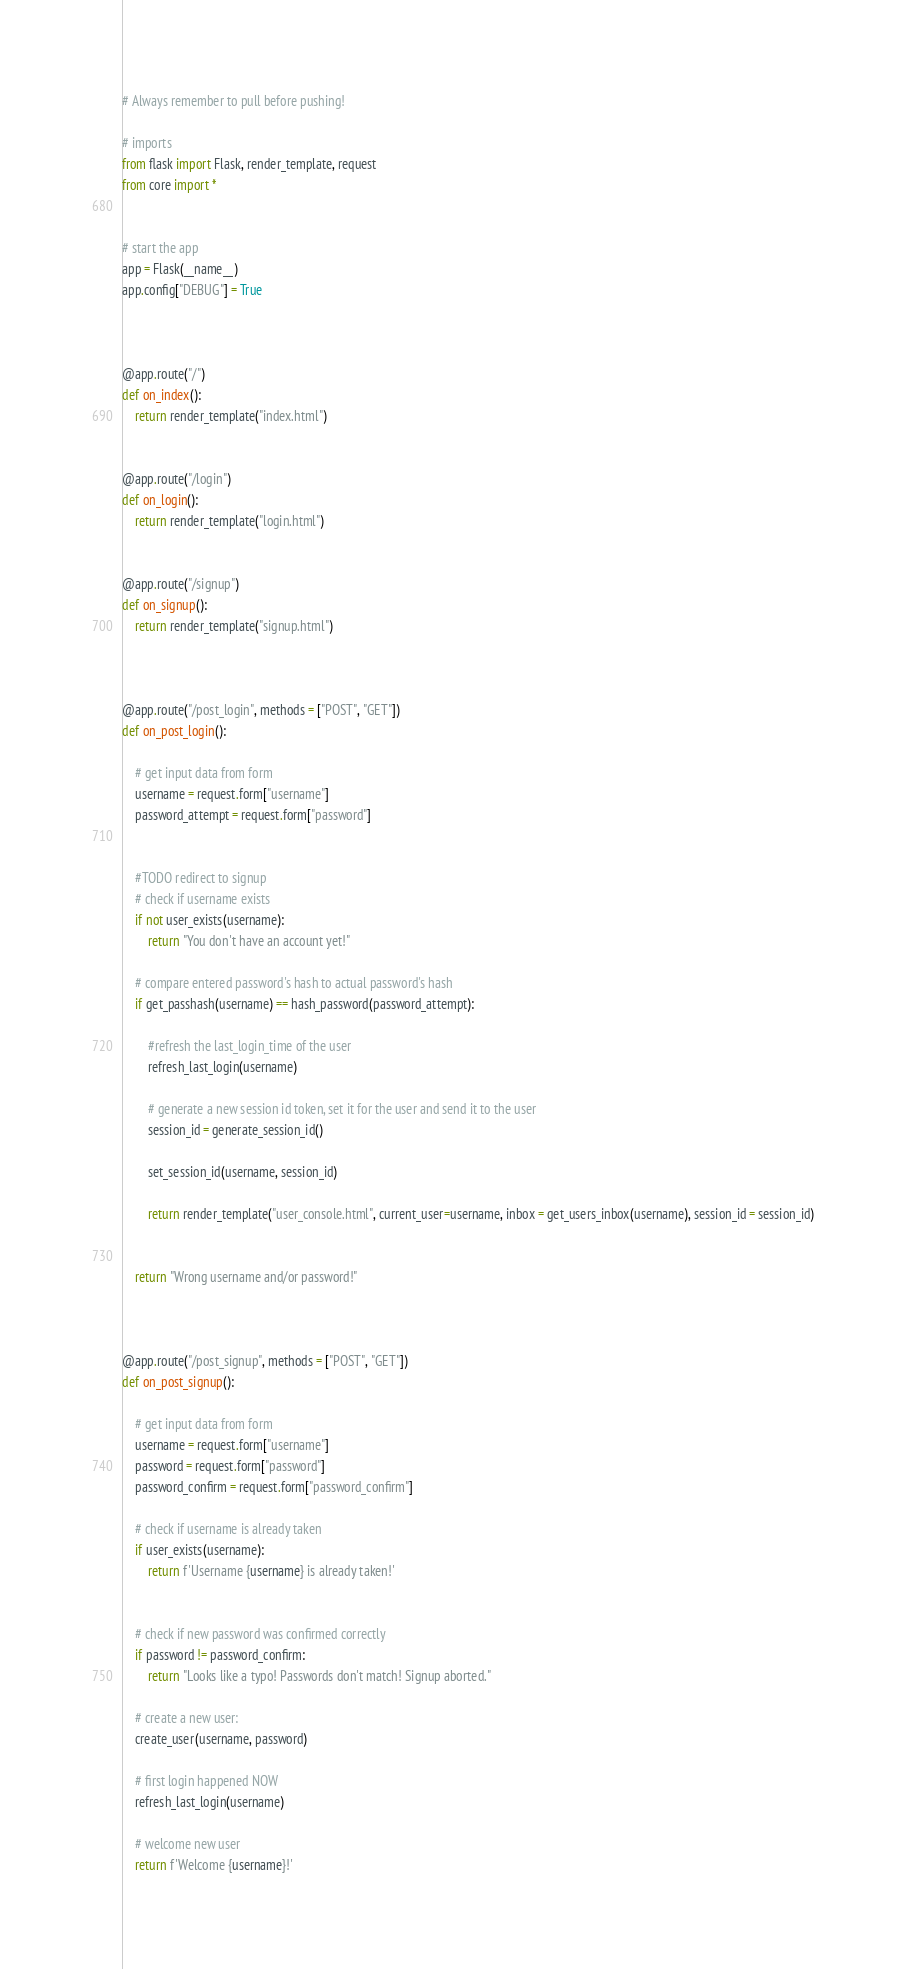<code> <loc_0><loc_0><loc_500><loc_500><_Python_># Always remember to pull before pushing!

# imports
from flask import Flask, render_template, request
from core import *


# start the app
app = Flask(__name__)
app.config["DEBUG"] = True



@app.route("/")
def on_index():
    return render_template("index.html")


@app.route("/login")
def on_login():
    return render_template("login.html")


@app.route("/signup")
def on_signup():
    return render_template("signup.html")



@app.route("/post_login", methods = ["POST", "GET"])
def on_post_login():

    # get input data from form
    username = request.form["username"]
    password_attempt = request.form["password"]


    #TODO redirect to signup
    # check if username exists
    if not user_exists(username):
        return "You don't have an account yet!"

    # compare entered password's hash to actual password's hash
    if get_passhash(username) == hash_password(password_attempt):
 
        #refresh the last_login_time of the user
        refresh_last_login(username)

        # generate a new session id token, set it for the user and send it to the user
        session_id = generate_session_id()

        set_session_id(username, session_id)

        return render_template("user_console.html", current_user=username, inbox = get_users_inbox(username), session_id = session_id)


    return "Wrong username and/or password!"    



@app.route("/post_signup", methods = ["POST", "GET"])
def on_post_signup():

    # get input data from form
    username = request.form["username"]
    password = request.form["password"]
    password_confirm = request.form["password_confirm"]

    # check if username is already taken
    if user_exists(username):
        return f'Username {username} is already taken!'


    # check if new password was confirmed correctly
    if password != password_confirm:
        return "Looks like a typo! Passwords don't match! Signup aborted."

    # create a new user:
    create_user(username, password)

    # first login happened NOW
    refresh_last_login(username)

    # welcome new user
    return f'Welcome {username}!'

</code> 